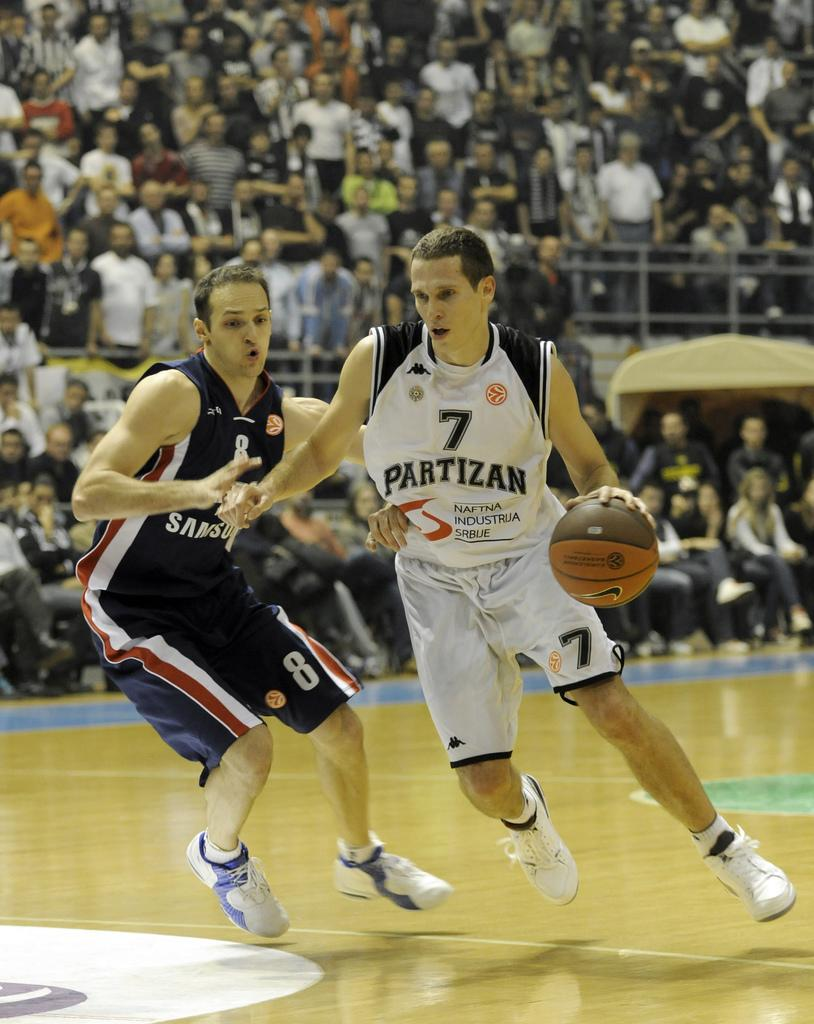How many people are in the image? There are two men in the image. What activity are the men engaged in? The men are playing basketball. Is there any indication of a competition in the image? Yes, it appears to be a competition. How many audience members can be seen in the background? There are many audience members in the background. What idea does the crowd in the image have about the basketball game? There is no crowd mentioned in the image, only audience members. What process is the person holding a camera using to take a picture of the building? The image does not show a person holding a camera or taking a picture of a building. 